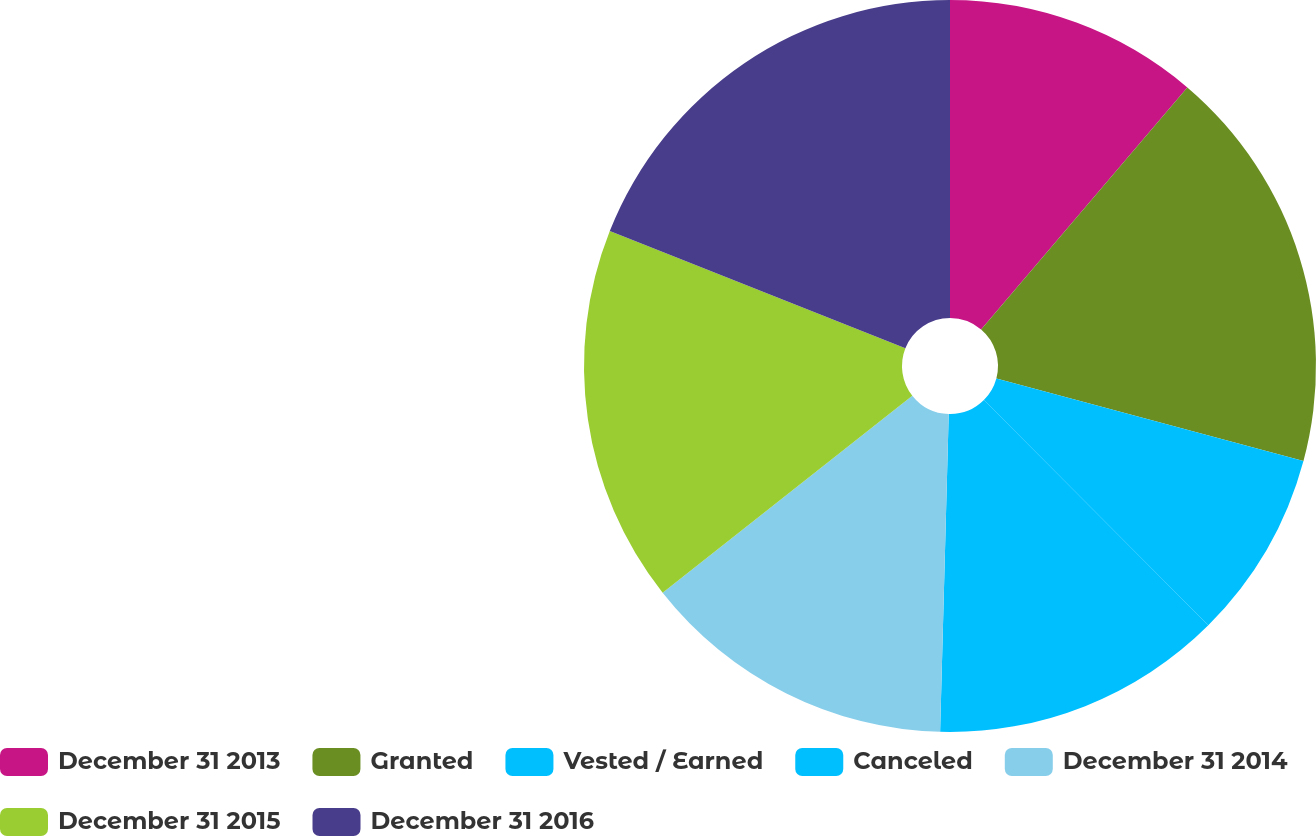Convert chart. <chart><loc_0><loc_0><loc_500><loc_500><pie_chart><fcel>December 31 2013<fcel>Granted<fcel>Vested / Earned<fcel>Canceled<fcel>December 31 2014<fcel>December 31 2015<fcel>December 31 2016<nl><fcel>11.23%<fcel>17.95%<fcel>8.35%<fcel>12.9%<fcel>13.94%<fcel>16.64%<fcel>18.99%<nl></chart> 